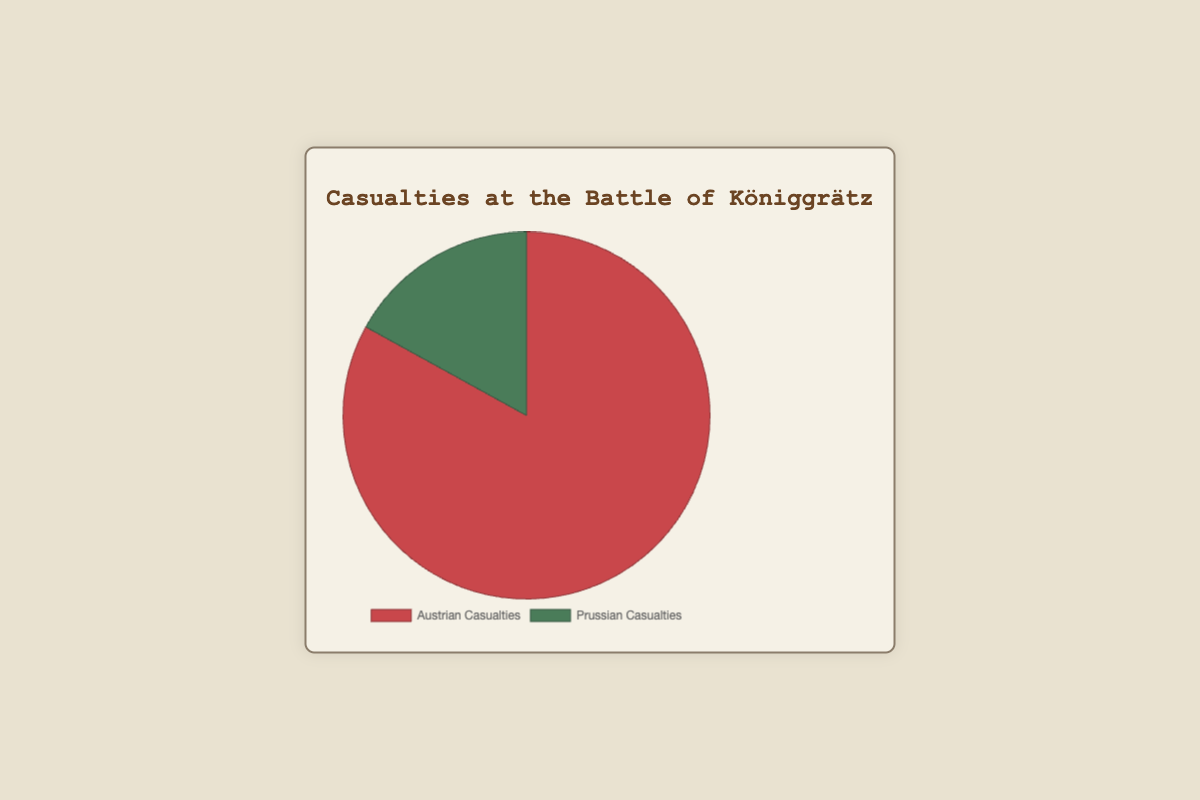What proportion of the casualties were Austrian? To find the proportion of Austrian casualties, divide the Austrian casualties by the total casualties and multiply by 100. The total casualties are 44,000 (Austrian) + 9,000 (Prussian) = 53,000. The proportion is (44,000 / 53,000) * 100 ≈ 83.02%
Answer: Approximately 83.02% Which side suffered more casualties? Based on the values given in the chart, 44,000 Austrian soldiers were casualties while 9,000 Prussian soldiers were casualties. Therefore, Austria suffered more casualties.
Answer: Austria By how much did Austrian casualties exceed Prussian casualties? To determine how much Austrian casualties exceed Prussian casualties, subtract the Prussian casualties (9,000) from the Austrian casualties (44,000). The difference is 44,000 - 9,000 = 35,000.
Answer: 35,000 How do the colors represent the casualties on the chart? The chart uses different colors to represent Austrian and Prussian casualties. The portion representing Austrian casualties is red, and the portion representing Prussian casualties is green.
Answer: Red for Austrian and Green for Prussian What is the ratio of Austrian casualties to Prussian casualties? The ratio of Austrian casualties to Prussian casualties is calculated by dividing the number of Austrian casualties by the number of Prussian casualties. The ratio is 44,000 / 9,000 ≈ 4.89.
Answer: Approximately 4.89 What is the total number of casualties at the Battle of Königgrätz? The total number of casualties is the sum of Austrian and Prussian casualties. So, add 44,000 (Austrian) to 9,000 (Prussian), resulting in 44,000 + 9,000 = 53,000.
Answer: 53,000 If the identities of the colors were swapped, what would the new color for Austrian casualties be? Currently, red represents Austrian casualties. If the colors were swapped, then green (which currently represents Prussian casualties) would now represent Austrian casualties.
Answer: Green Are Austrian casualties more than three times the Prussian casualties? To check if Austrian casualties are more than three times the Prussian casualties, multiply Prussian casualties by 3 and compare to Austrian casualties. 3 * 9,000 = 27,000. Since 44,000 (Austrian) > 27,000, Austrian casualties are indeed more than three times the Prussian casualties.
Answer: Yes What is the difference, in percentage terms, between Austrian and Prussian casualties? First, find the absolute difference in casualties which is 44,000 - 9,000 = 35,000. Then, divide this difference by the total number of casualties (53,000) and multiply by 100 to get the percentage difference: (35,000 / 53,000) * 100 ≈ 66.04%.
Answer: Approximately 66.04% If the Prussian casualties increased by 3,000, how would that affect the proportion of Austrian casualties? If Prussian casualties increased by 3,000, the new figures would be 44,000 (Austrian) and 12,000 (Prussian). The total casualties would then be 44,000 + 12,000 = 56,000. The new proportion of Austrian casualties is (44,000 / 56,000) * 100 ≈ 78.57%.
Answer: Approximately 78.57% 